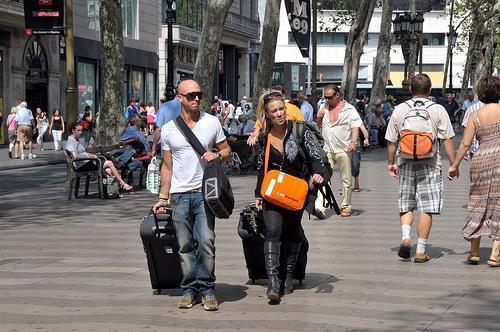How many suitcases are visible?
Give a very brief answer. 2. How many people are there?
Give a very brief answer. 6. 